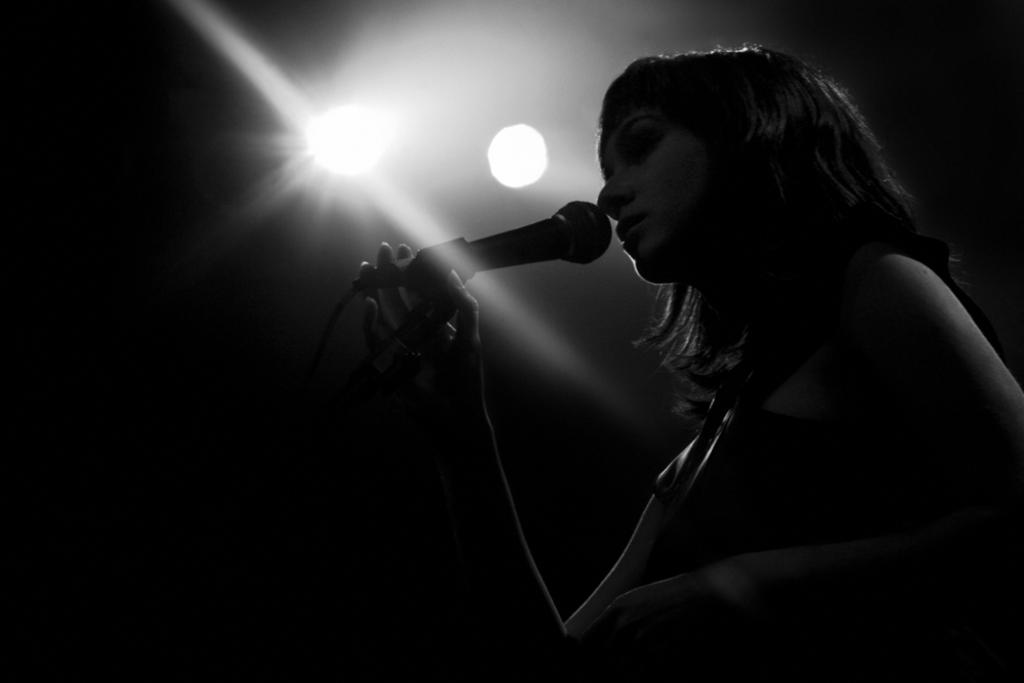What is the person in the image holding? The person is holding a microphone. What can be seen at the top of the image? There are lights visible at the top of the image. How many pizzas are being attacked by the fold in the image? There are no pizzas or folds present in the image. 